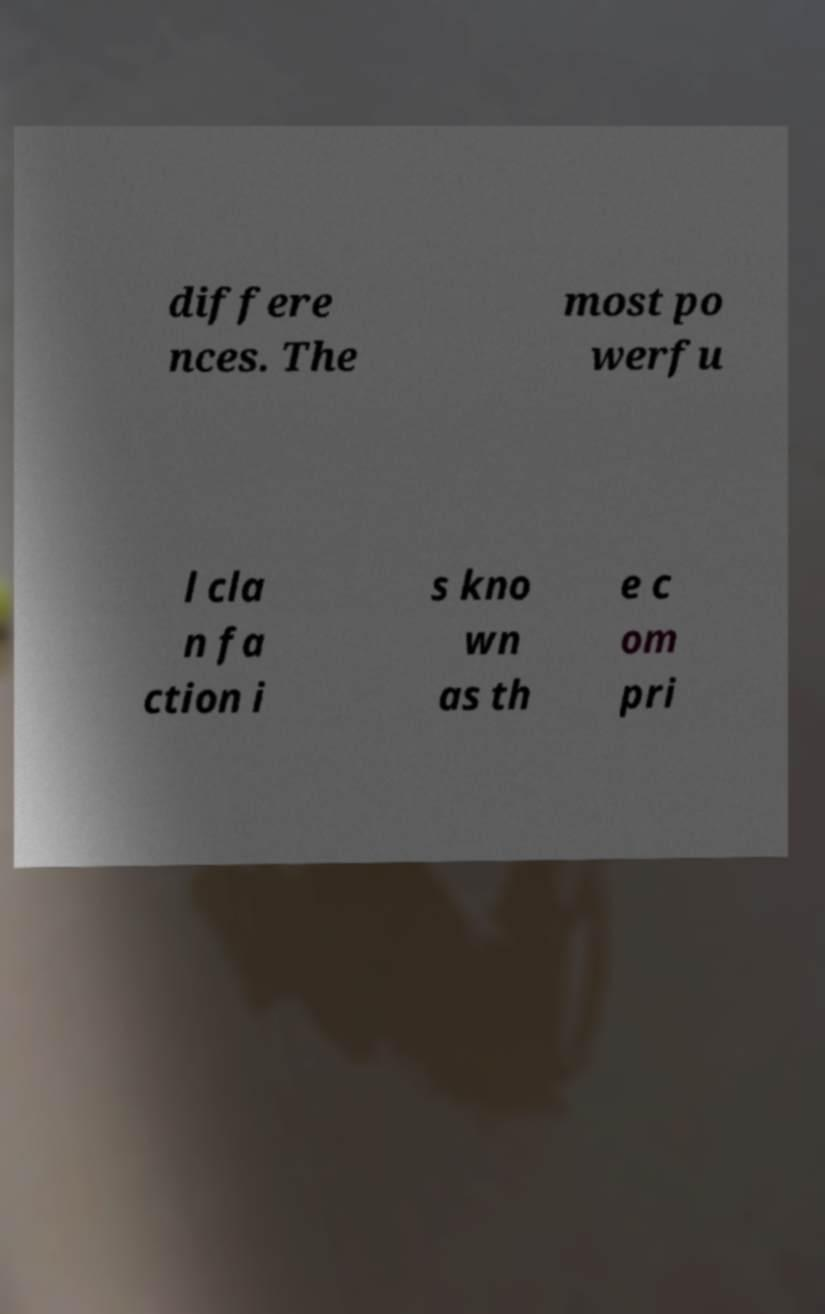Can you accurately transcribe the text from the provided image for me? differe nces. The most po werfu l cla n fa ction i s kno wn as th e c om pri 